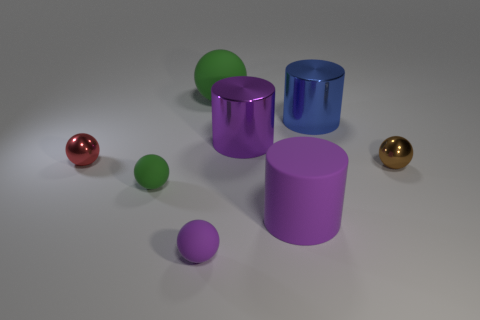The purple thing that is in front of the large rubber object that is in front of the large blue cylinder is made of what material?
Make the answer very short. Rubber. There is a small matte thing that is behind the matte object on the right side of the green matte sphere on the right side of the small purple ball; what shape is it?
Offer a very short reply. Sphere. There is a tiny object that is right of the large rubber ball; is its shape the same as the shiny thing that is left of the big sphere?
Ensure brevity in your answer.  Yes. What number of other objects are there of the same material as the purple sphere?
Make the answer very short. 3. What shape is the brown object that is the same material as the red ball?
Keep it short and to the point. Sphere. Does the blue shiny object have the same size as the purple rubber ball?
Provide a succinct answer. No. There is a purple cylinder that is behind the purple matte object that is right of the big ball; how big is it?
Your answer should be very brief. Large. What shape is the small rubber thing that is the same color as the big matte cylinder?
Give a very brief answer. Sphere. How many balls are red objects or large purple things?
Offer a terse response. 1. There is a brown shiny object; does it have the same size as the rubber object behind the small brown thing?
Your answer should be very brief. No. 